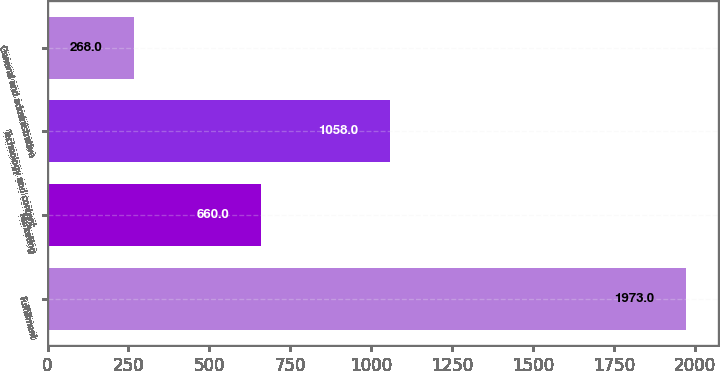<chart> <loc_0><loc_0><loc_500><loc_500><bar_chart><fcel>Fulfillment<fcel>Marketing<fcel>Technology and content<fcel>General and administrative<nl><fcel>1973<fcel>660<fcel>1058<fcel>268<nl></chart> 